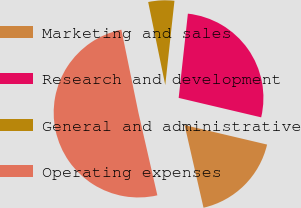Convert chart. <chart><loc_0><loc_0><loc_500><loc_500><pie_chart><fcel>Marketing and sales<fcel>Research and development<fcel>General and administrative<fcel>Operating expenses<nl><fcel>17.73%<fcel>26.95%<fcel>4.96%<fcel>50.35%<nl></chart> 